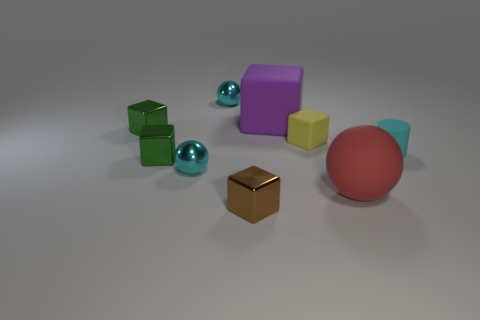Is the brown object the same size as the rubber sphere?
Offer a terse response. No. Is the number of things left of the tiny brown metal thing greater than the number of tiny cyan cylinders?
Offer a terse response. Yes. There is a yellow cube that is the same material as the big ball; what is its size?
Your answer should be compact. Small. Are there any large spheres in front of the matte cylinder?
Keep it short and to the point. Yes. Is the big red rubber thing the same shape as the large purple matte object?
Give a very brief answer. No. What size is the shiny sphere that is in front of the cyan object right of the sphere right of the brown thing?
Your response must be concise. Small. What is the material of the big purple thing?
Keep it short and to the point. Rubber. Do the cyan matte object and the green metallic object that is in front of the small yellow thing have the same shape?
Provide a succinct answer. No. There is a tiny cube that is in front of the sphere to the right of the shiny thing in front of the big red matte sphere; what is its material?
Your answer should be very brief. Metal. How many large green matte cubes are there?
Your answer should be very brief. 0. 